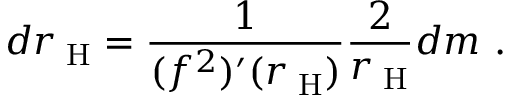<formula> <loc_0><loc_0><loc_500><loc_500>d r _ { H } = \frac { 1 } { ( f ^ { 2 } ) ^ { \prime } ( r _ { H } ) } \frac { 2 } { r _ { H } } d m \ .</formula> 